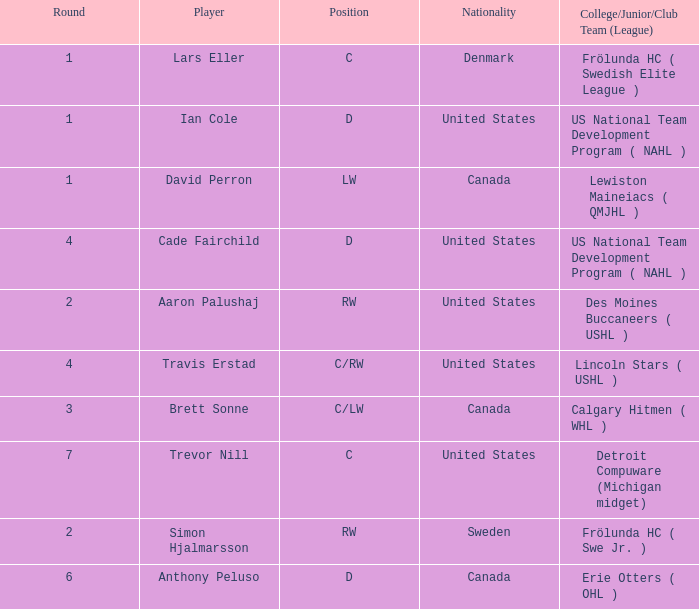What is the position of the player from round 2 from Sweden? RW. 